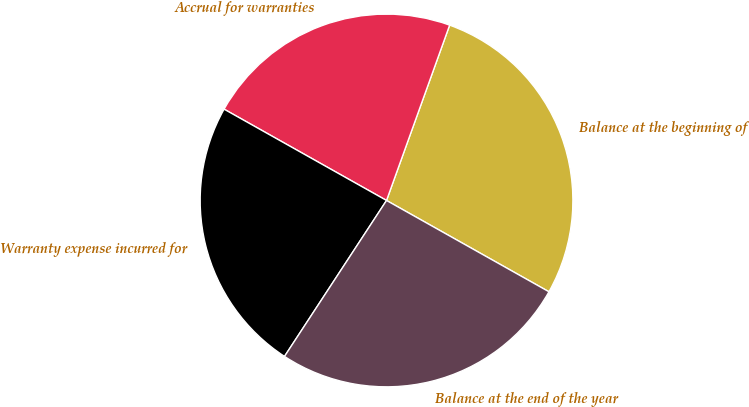<chart> <loc_0><loc_0><loc_500><loc_500><pie_chart><fcel>Balance at the beginning of<fcel>Accrual for warranties<fcel>Warranty expense incurred for<fcel>Balance at the end of the year<nl><fcel>27.65%<fcel>22.35%<fcel>23.93%<fcel>26.07%<nl></chart> 